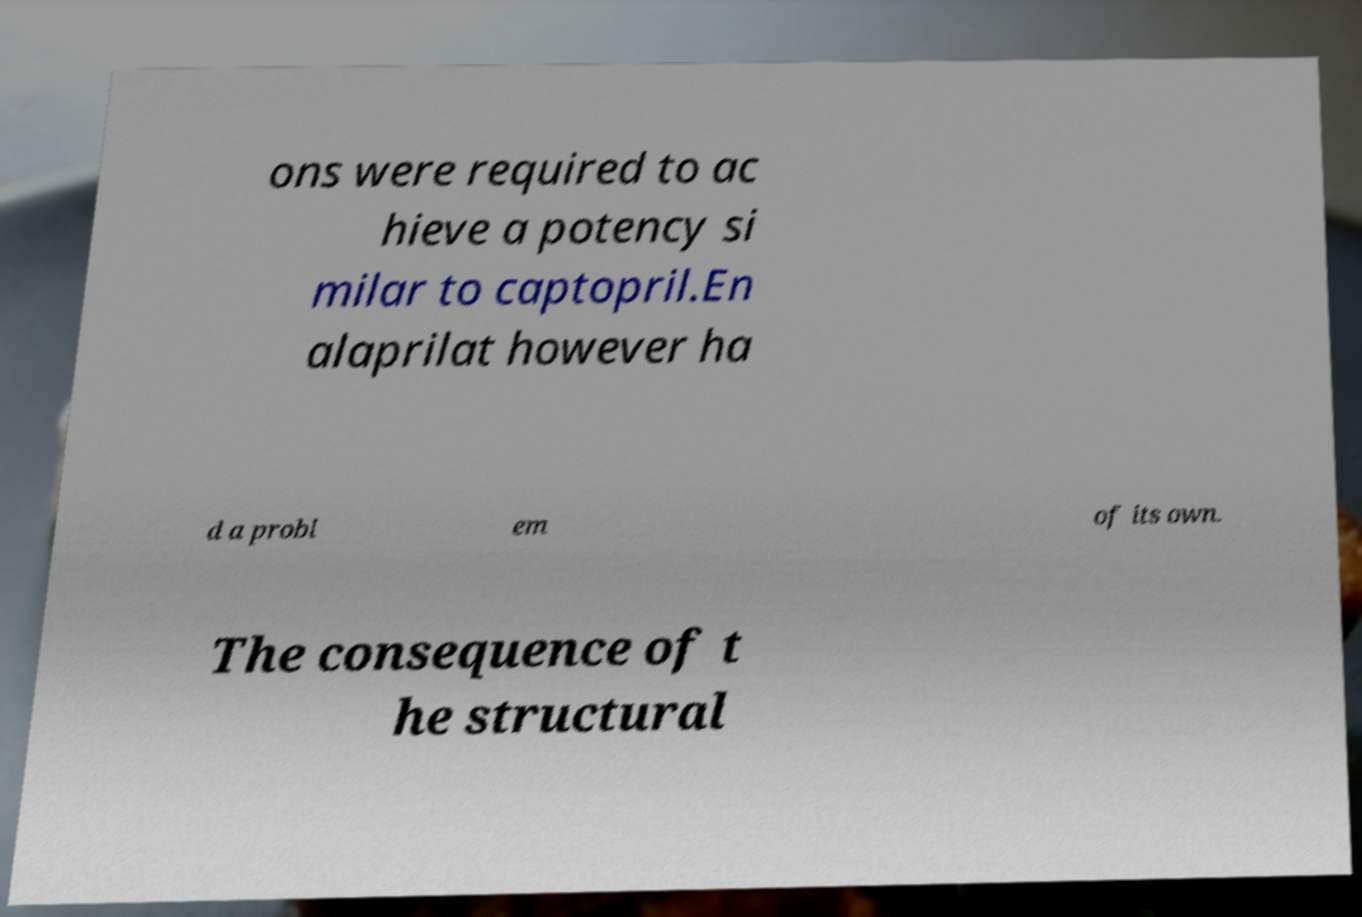Can you read and provide the text displayed in the image?This photo seems to have some interesting text. Can you extract and type it out for me? ons were required to ac hieve a potency si milar to captopril.En alaprilat however ha d a probl em of its own. The consequence of t he structural 